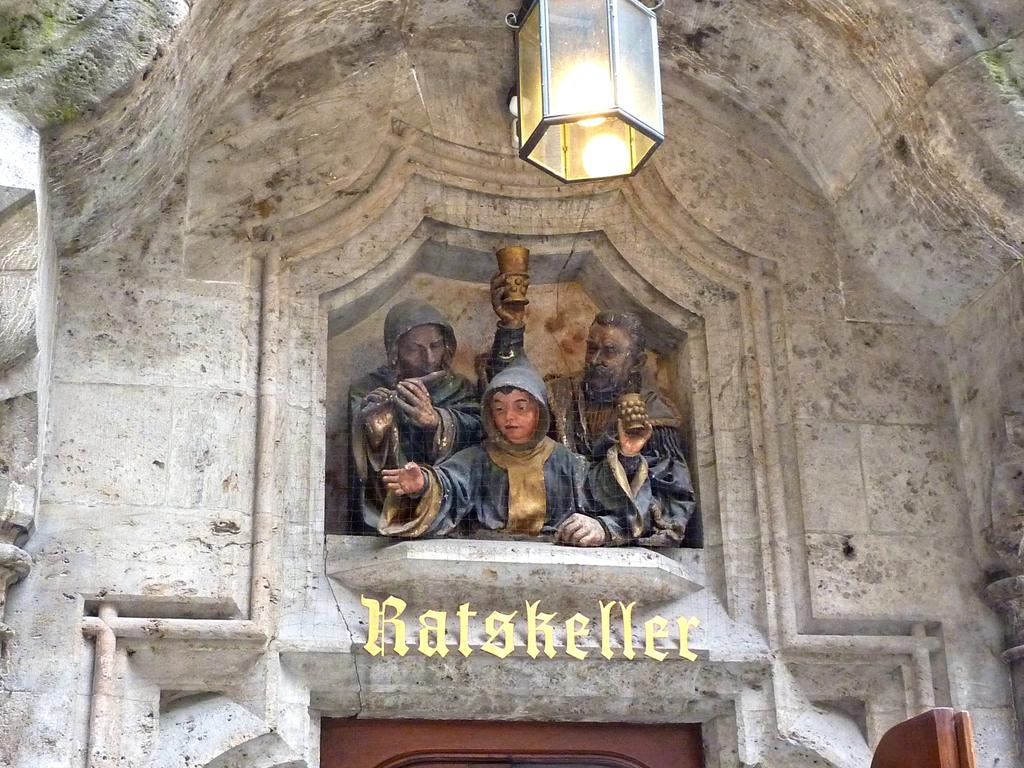What type of structure is visible in the image? There is a building in the image. What artistic elements can be seen in the image? There are sculptures in the image. Is there any source of illumination visible in the image? Yes, there is a light in the image. What type of text or symbols can be seen in the image? There is writing in the image. What type of liquid is being poured from the wrist in the image? There is no liquid or wrist present in the image. 